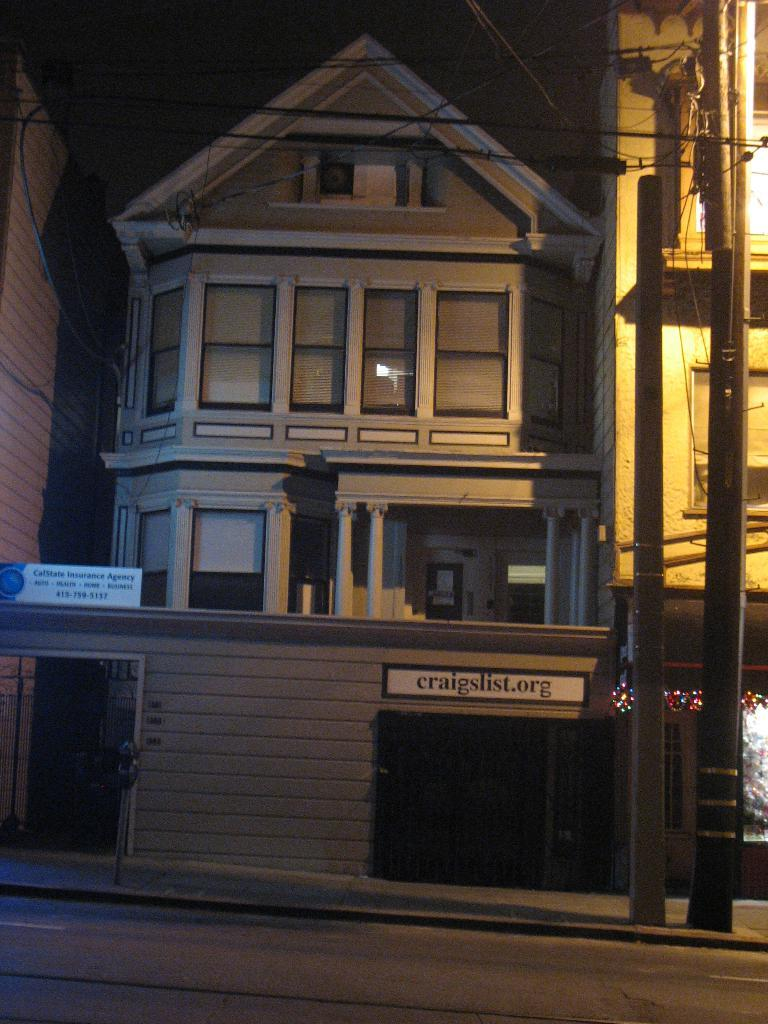What type of structures can be seen in the image? There are buildings in the image. What is written or displayed on the boards in the image? There are boards with text in the image. What type of infrastructure is present in the image? There are electric poles and wires in the image. What type of illumination is visible in the image? There are lights in the image. What architectural features can be seen on the buildings? There are windows visible in the image. What type of silk is being used to create the coil in the image? There is no coil or silk present in the image. What type of dinner is being served in the image? There is no dinner or food present in the image. 